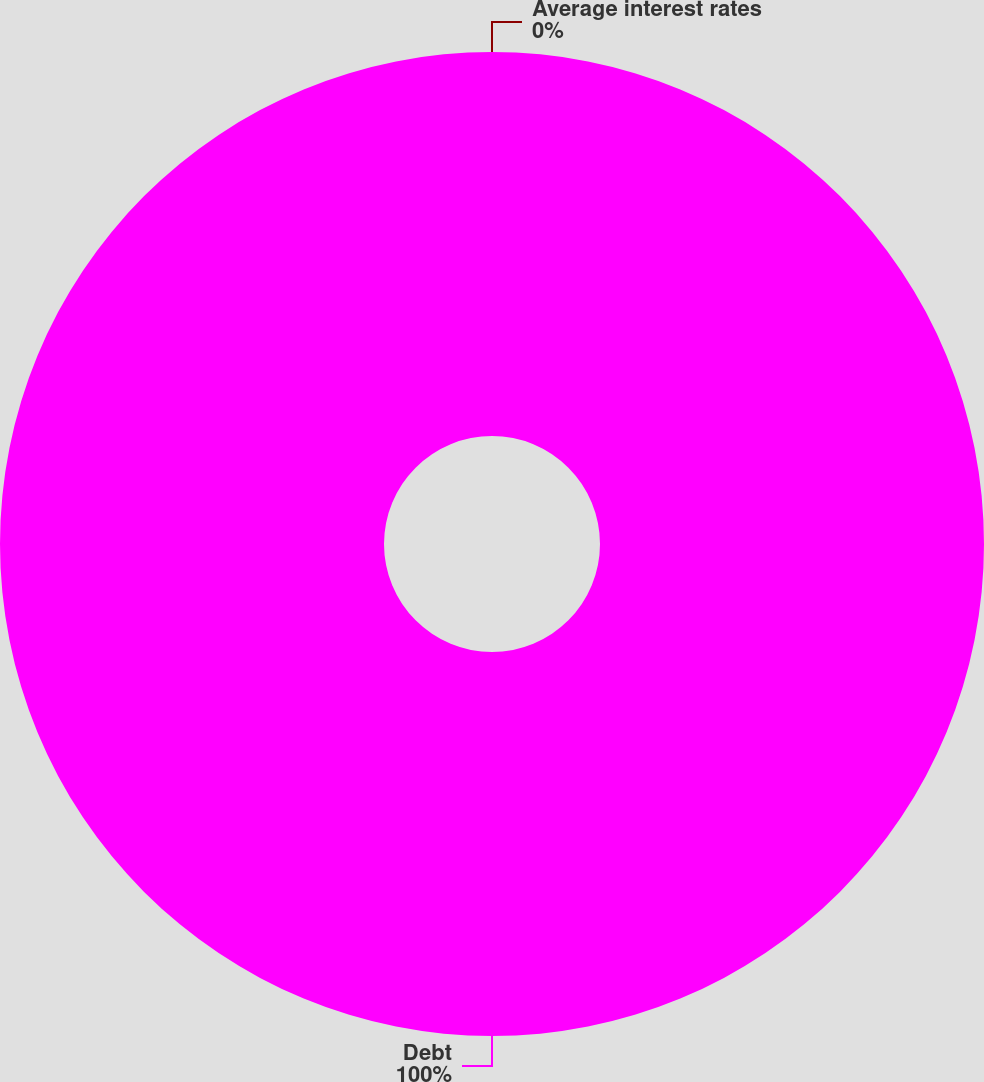Convert chart to OTSL. <chart><loc_0><loc_0><loc_500><loc_500><pie_chart><fcel>Debt<fcel>Average interest rates<nl><fcel>100.0%<fcel>0.0%<nl></chart> 